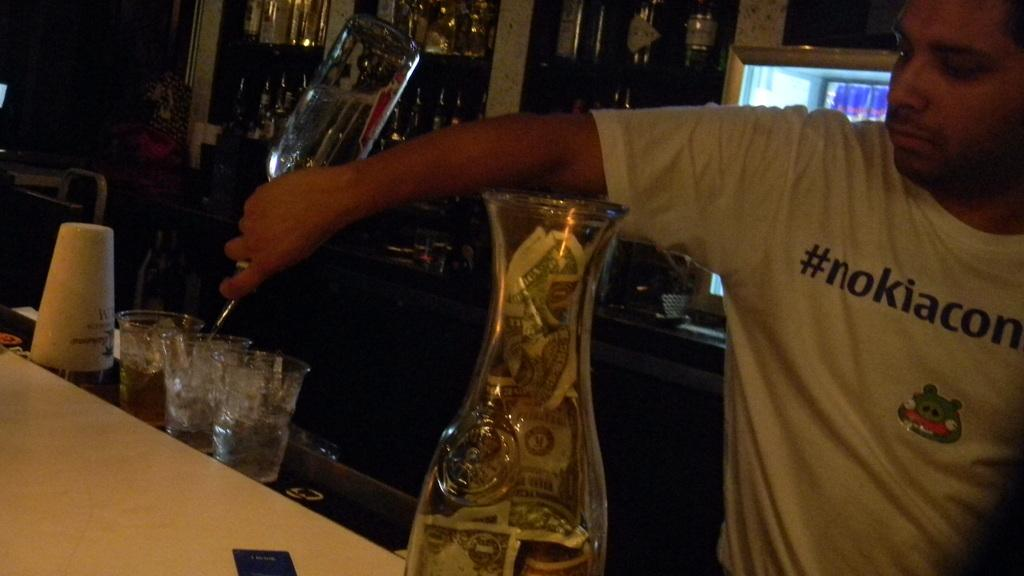Who or what is the main subject in the image? There is a person in the image. What object is present in the image that the person might use? There is a table in the image that the person might use. What can be found on the table in the image? The table has glasses and plastic bottles. Are there any additional objects visible behind the person? Yes, there are additional bottles behind the background of the person. How would you describe the lighting in the image? The background of the image is dark. What type of note is the person holding in the image? There is no note present in the image; the person is not holding anything. 